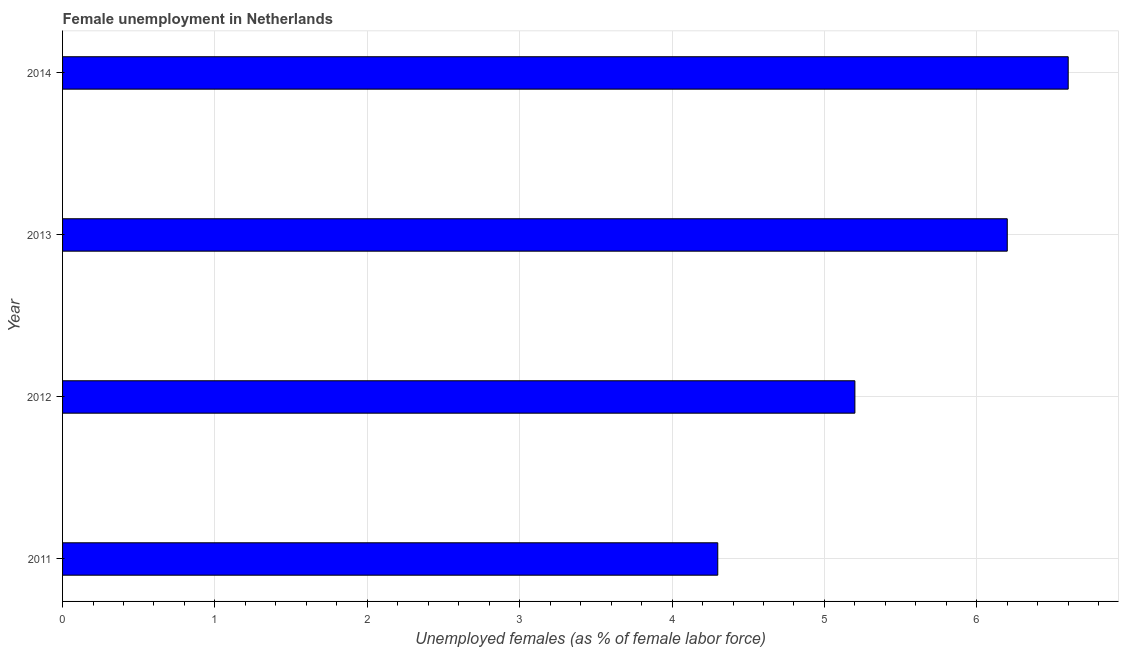Does the graph contain grids?
Provide a succinct answer. Yes. What is the title of the graph?
Keep it short and to the point. Female unemployment in Netherlands. What is the label or title of the X-axis?
Offer a very short reply. Unemployed females (as % of female labor force). What is the label or title of the Y-axis?
Your answer should be compact. Year. What is the unemployed females population in 2014?
Provide a short and direct response. 6.6. Across all years, what is the maximum unemployed females population?
Your response must be concise. 6.6. Across all years, what is the minimum unemployed females population?
Provide a succinct answer. 4.3. In which year was the unemployed females population maximum?
Your answer should be compact. 2014. What is the sum of the unemployed females population?
Provide a succinct answer. 22.3. What is the difference between the unemployed females population in 2011 and 2012?
Ensure brevity in your answer.  -0.9. What is the average unemployed females population per year?
Your answer should be very brief. 5.58. What is the median unemployed females population?
Your answer should be very brief. 5.7. Do a majority of the years between 2011 and 2012 (inclusive) have unemployed females population greater than 5.6 %?
Ensure brevity in your answer.  No. What is the ratio of the unemployed females population in 2013 to that in 2014?
Provide a short and direct response. 0.94. Is the unemployed females population in 2012 less than that in 2013?
Provide a succinct answer. Yes. What is the difference between the highest and the second highest unemployed females population?
Keep it short and to the point. 0.4. In how many years, is the unemployed females population greater than the average unemployed females population taken over all years?
Offer a very short reply. 2. How many years are there in the graph?
Keep it short and to the point. 4. Are the values on the major ticks of X-axis written in scientific E-notation?
Your response must be concise. No. What is the Unemployed females (as % of female labor force) in 2011?
Provide a short and direct response. 4.3. What is the Unemployed females (as % of female labor force) of 2012?
Make the answer very short. 5.2. What is the Unemployed females (as % of female labor force) of 2013?
Make the answer very short. 6.2. What is the Unemployed females (as % of female labor force) in 2014?
Keep it short and to the point. 6.6. What is the difference between the Unemployed females (as % of female labor force) in 2011 and 2013?
Your response must be concise. -1.9. What is the difference between the Unemployed females (as % of female labor force) in 2012 and 2013?
Your response must be concise. -1. What is the difference between the Unemployed females (as % of female labor force) in 2012 and 2014?
Keep it short and to the point. -1.4. What is the ratio of the Unemployed females (as % of female labor force) in 2011 to that in 2012?
Make the answer very short. 0.83. What is the ratio of the Unemployed females (as % of female labor force) in 2011 to that in 2013?
Make the answer very short. 0.69. What is the ratio of the Unemployed females (as % of female labor force) in 2011 to that in 2014?
Provide a short and direct response. 0.65. What is the ratio of the Unemployed females (as % of female labor force) in 2012 to that in 2013?
Give a very brief answer. 0.84. What is the ratio of the Unemployed females (as % of female labor force) in 2012 to that in 2014?
Provide a succinct answer. 0.79. What is the ratio of the Unemployed females (as % of female labor force) in 2013 to that in 2014?
Give a very brief answer. 0.94. 